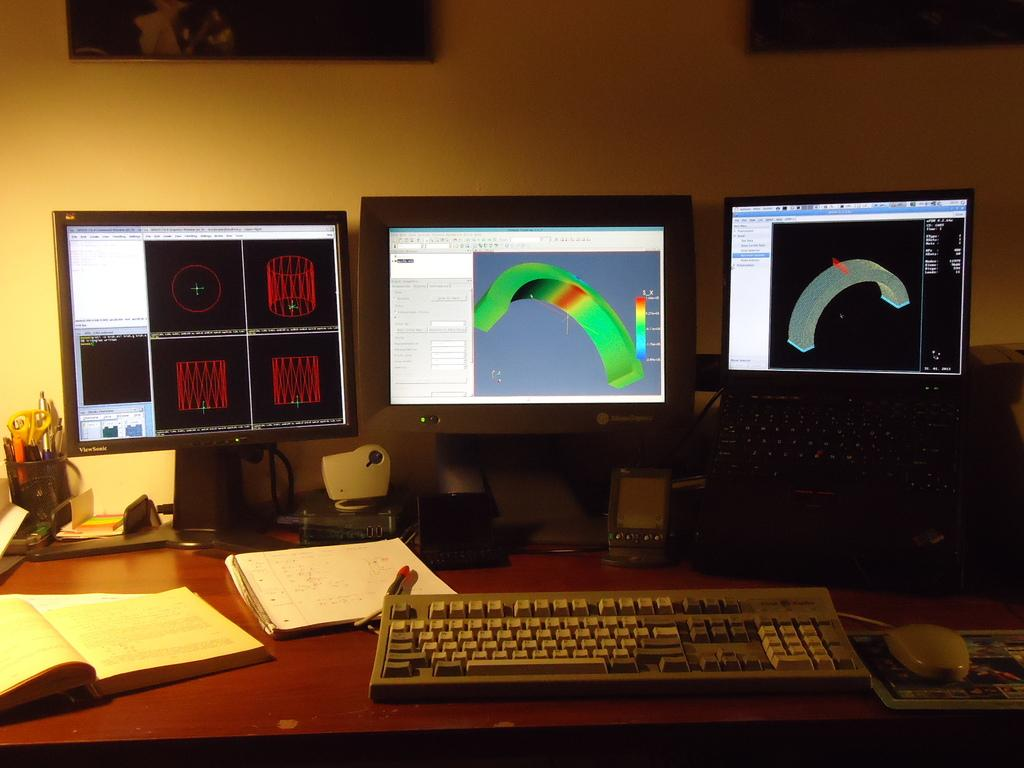How many computers are visible in the image? There are 3 computers in the image. What input device is present in the image? There is 1 keyboard and 1 mouse in the image. How many speakers are visible in the image? There are 2 speakers in the image. What is used for holding stationery items in the image? There is 1 pen stand in the image. How many books are visible in the image? There are 2 books in the image. What is the writing instrument visible in the image? There is 1 pen in the image. What can be seen on the wall in the image? There are 2 photo frames on the wall in the image. What type of straw is being used by the governor in the image? There is no governor or straw present in the image. Can you describe the bee's activity in the image? There are no bees present in the image. 